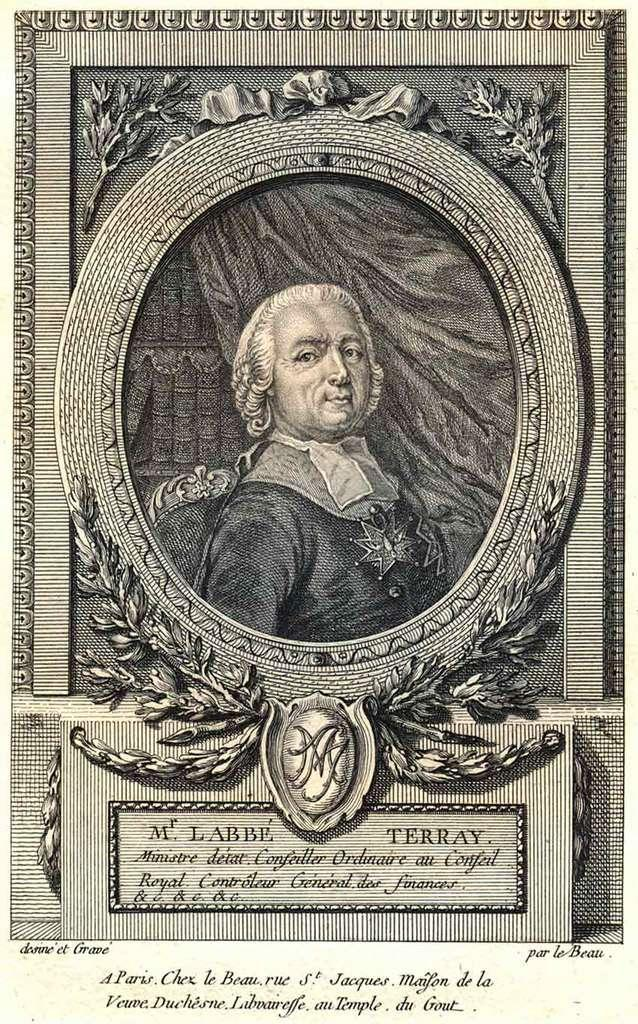<image>
Relay a brief, clear account of the picture shown. A vintage painting in an ornate frame of M. Labbe Terray. 